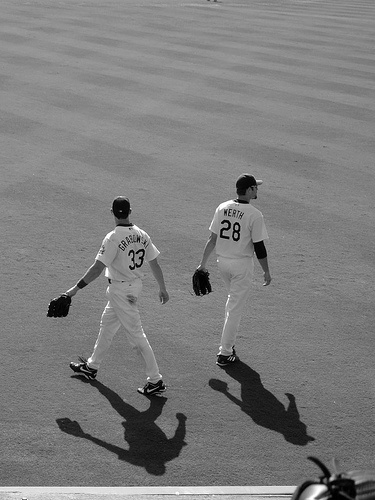Describe the objects in this image and their specific colors. I can see people in gray, black, and lightgray tones, people in gray, black, and lightgray tones, baseball glove in gray, black, darkgray, and lightgray tones, and baseball glove in black and gray tones in this image. 